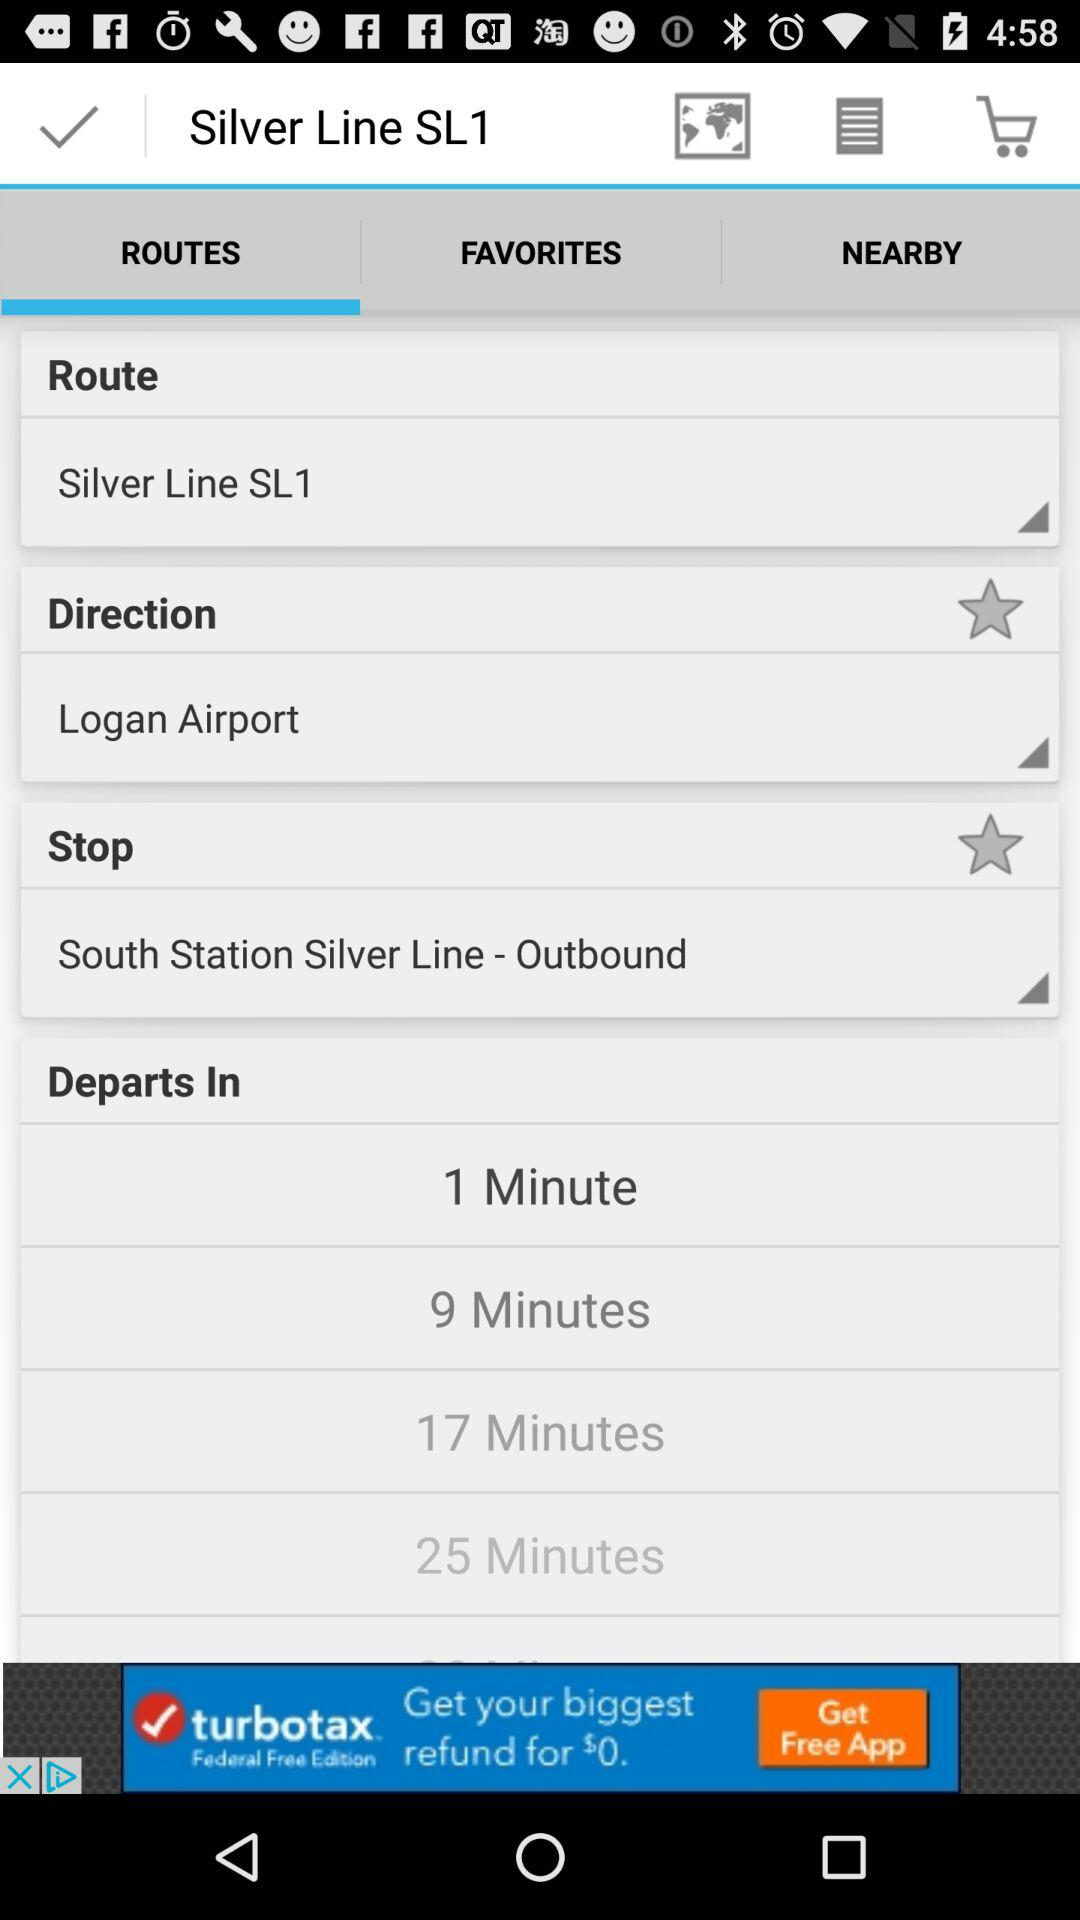What is the selected stop? The selected stop is "South Station Silver Line - Outbound". 